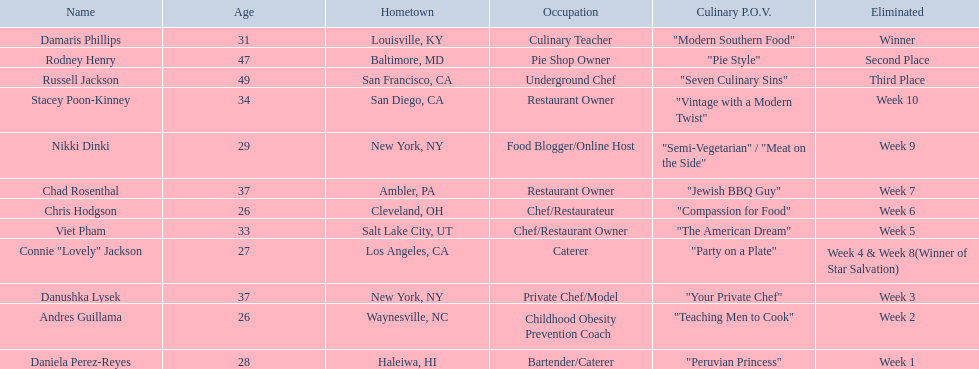Excluding the winner, and second and third place winners, who were the contestants eliminated? Stacey Poon-Kinney, Nikki Dinki, Chad Rosenthal, Chris Hodgson, Viet Pham, Connie "Lovely" Jackson, Danushka Lysek, Andres Guillama, Daniela Perez-Reyes. Of these contestants, who were the last five eliminated before the winner, second, and third place winners were announce? Stacey Poon-Kinney, Nikki Dinki, Chad Rosenthal, Chris Hodgson, Viet Pham. Of these five contestants, was nikki dinki or viet pham eliminated first? Viet Pham. Who were the participants in the food network? Damaris Phillips, Rodney Henry, Russell Jackson, Stacey Poon-Kinney, Nikki Dinki, Chad Rosenthal, Chris Hodgson, Viet Pham, Connie "Lovely" Jackson, Danushka Lysek, Andres Guillama, Daniela Perez-Reyes. When was nikki dinki expelled? Week 9. When was viet pham expelled? Week 5. Which of these two events happened earlier? Week 5. Parse the full table in json format. {'header': ['Name', 'Age', 'Hometown', 'Occupation', 'Culinary P.O.V.', 'Eliminated'], 'rows': [['Damaris Phillips', '31', 'Louisville, KY', 'Culinary Teacher', '"Modern Southern Food"', 'Winner'], ['Rodney Henry', '47', 'Baltimore, MD', 'Pie Shop Owner', '"Pie Style"', 'Second Place'], ['Russell Jackson', '49', 'San Francisco, CA', 'Underground Chef', '"Seven Culinary Sins"', 'Third Place'], ['Stacey Poon-Kinney', '34', 'San Diego, CA', 'Restaurant Owner', '"Vintage with a Modern Twist"', 'Week 10'], ['Nikki Dinki', '29', 'New York, NY', 'Food Blogger/Online Host', '"Semi-Vegetarian" / "Meat on the Side"', 'Week 9'], ['Chad Rosenthal', '37', 'Ambler, PA', 'Restaurant Owner', '"Jewish BBQ Guy"', 'Week 7'], ['Chris Hodgson', '26', 'Cleveland, OH', 'Chef/Restaurateur', '"Compassion for Food"', 'Week 6'], ['Viet Pham', '33', 'Salt Lake City, UT', 'Chef/Restaurant Owner', '"The American Dream"', 'Week 5'], ['Connie "Lovely" Jackson', '27', 'Los Angeles, CA', 'Caterer', '"Party on a Plate"', 'Week 4 & Week 8(Winner of Star Salvation)'], ['Danushka Lysek', '37', 'New York, NY', 'Private Chef/Model', '"Your Private Chef"', 'Week 3'], ['Andres Guillama', '26', 'Waynesville, NC', 'Childhood Obesity Prevention Coach', '"Teaching Men to Cook"', 'Week 2'], ['Daniela Perez-Reyes', '28', 'Haleiwa, HI', 'Bartender/Caterer', '"Peruvian Princess"', 'Week 1']]} Who was eliminated in the current week? Viet Pham. Which individuals are known as food network stars? Damaris Phillips, Rodney Henry, Russell Jackson, Stacey Poon-Kinney, Nikki Dinki, Chad Rosenthal, Chris Hodgson, Viet Pham, Connie "Lovely" Jackson, Danushka Lysek, Andres Guillama, Daniela Perez-Reyes. In which week was nikki dinki eliminated from the contest? Week 9. When did viet pham face elimination? Week 5. Which of these eliminations happened earlier? Week 5. Who was the person eliminated in the fifth week of the competition? Viet Pham. 